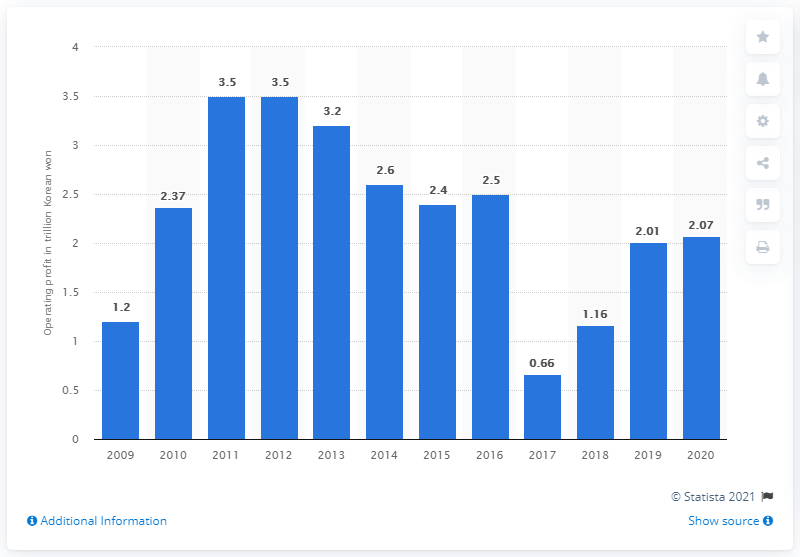Point out several critical features in this image. Kia Motors Corporation's operating profit in the 2019 fiscal year was 2.07 trillion Korean won. 